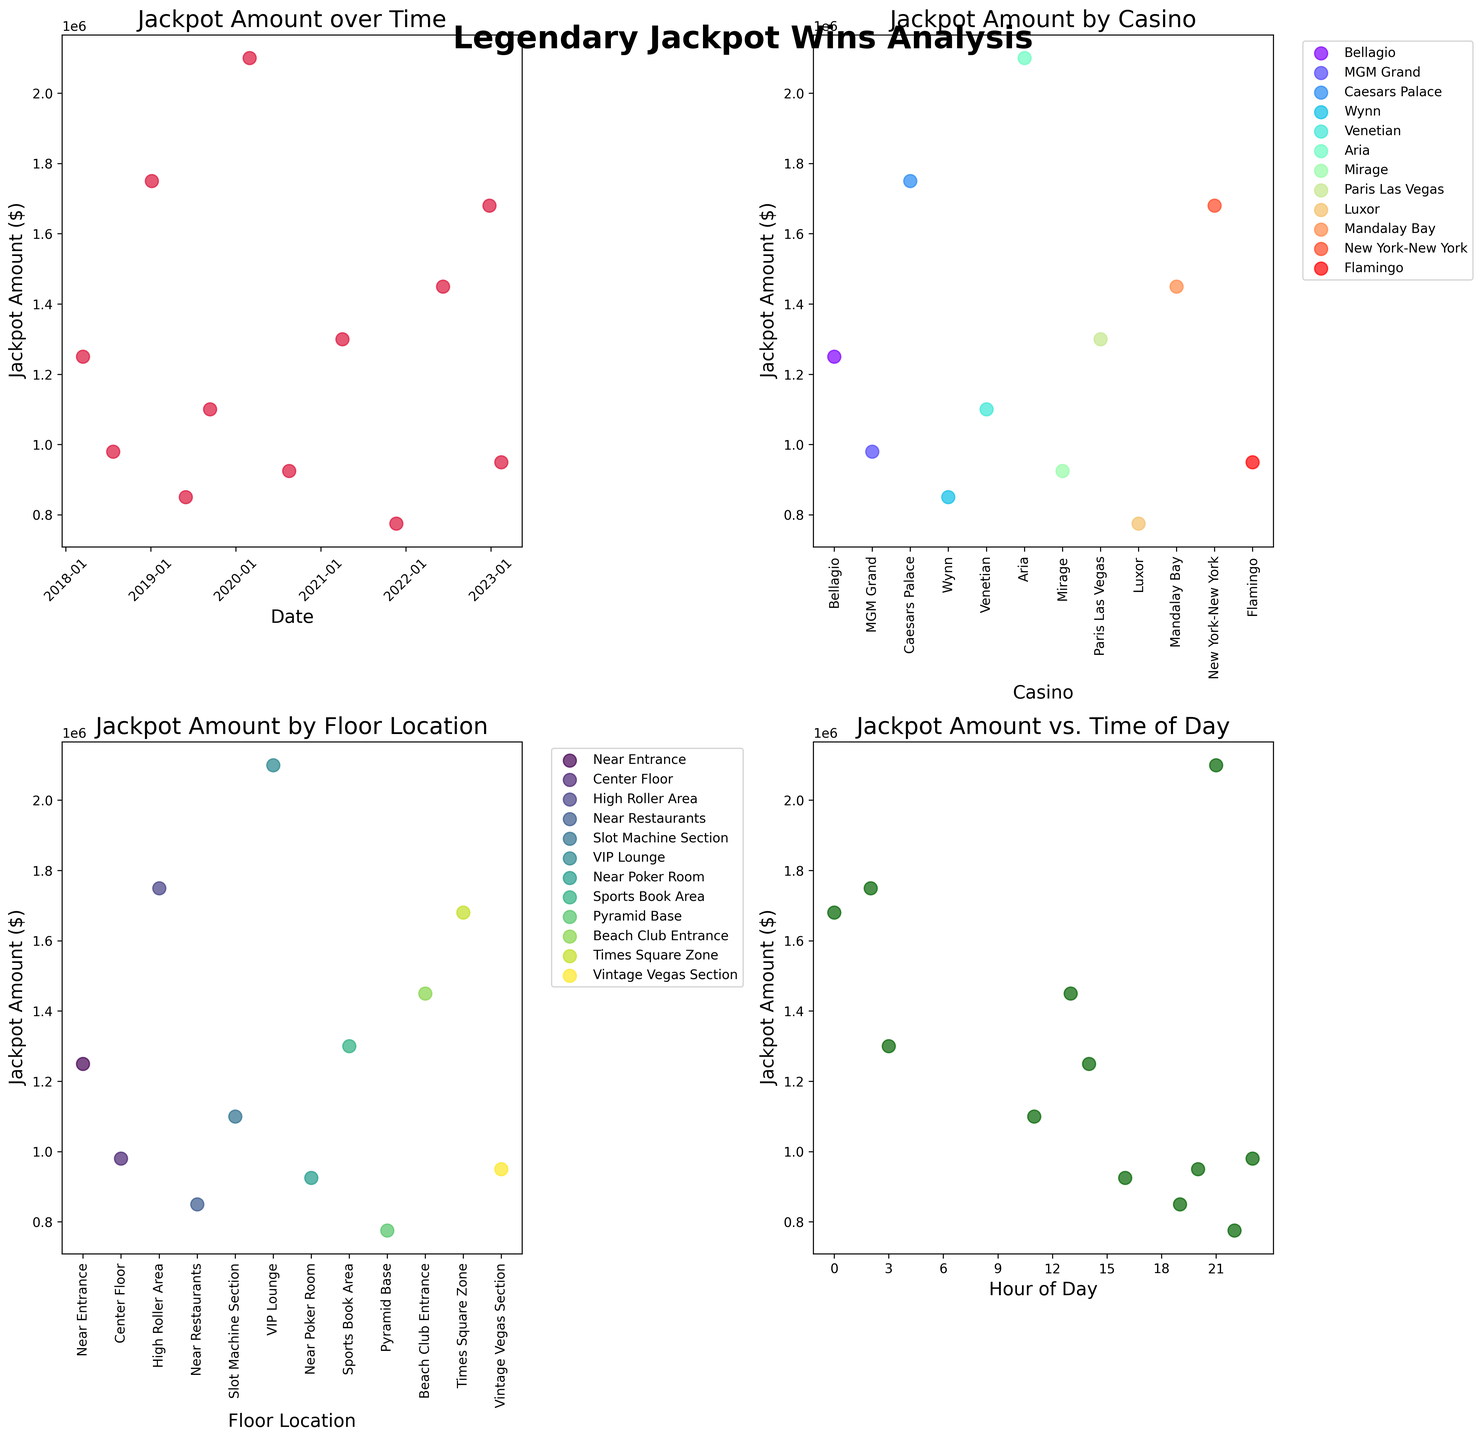What is the title of the figure? The title of the figure is displayed at the top and reads "Legendary Jackpot Wins Analysis."
Answer: Legendary Jackpot Wins Analysis What is the format of the x-axis labels in the scatter plot of Jackpot Amount over Time? The x-axis labels in the scatter plot of Jackpot Amount over Time are formatted as 'YYYY-MM' indicating the year and month.
Answer: YYYY-MM Which casino has the highest recorded jackpot amount and what is the value? By looking at the scatter plot of Jackpot Amount by Casino, the casino with the highest recorded jackpot amount is Aria with a jackpot amount of $2,100,000.
Answer: Aria, $2,100,000 How many jackpot wins are plotted for the floor location labeled "Near Entrance"? By examining the scatter plot of Jackpot Amount by Floor Location, we see that there is one data point for the floor location labeled "Near Entrance."
Answer: 1 Does the time of day have a distinct impact on the jackpot amounts won? By examining the scatter plot of Jackpot Amount vs. Time of Day, we notice that there isn’t a clear, distinct pattern or trend indicating that the time of day has a major impact on the jackpot amounts won.
Answer: No What is the range of the "Jackpot Amount ($)" on the y-axis in the scatter plot "Jackpot Amount by Floor Location"? The range of the "Jackpot Amount ($)" on the y-axis in the scatter plot "Jackpot Amount by Floor Location" spans from roughly $750,000 to $2,100,000.
Answer: $750,000 to $2,100,000 Which scatter plot shows the data labeled by different colors for each casino? The scatter plot "Jackpot Amount by Casino" uses different colors to label the data for each casino, identifiable through the legend on the plot.
Answer: Jackpot Amount by Casino What is the average jackpot amount for wins at Paris Las Vegas? By looking at the scatter plot of Jackpot Amount by Casino, we see that Paris Las Vegas had one significant jackpot win plotted. The amount for this win is $1,300,000, so the average is $1,300,000.
Answer: $1,300,000 During which hour was the jackpot win of $980,000 recorded? By checking the scatter plot of Jackpot Amount vs. Time of Day, and correlating this with the "Jackpot Amount by Casino" scatter plot, the $980,000 win at MGM Grand was recorded at 11:00 PM.
Answer: 11:00 PM 